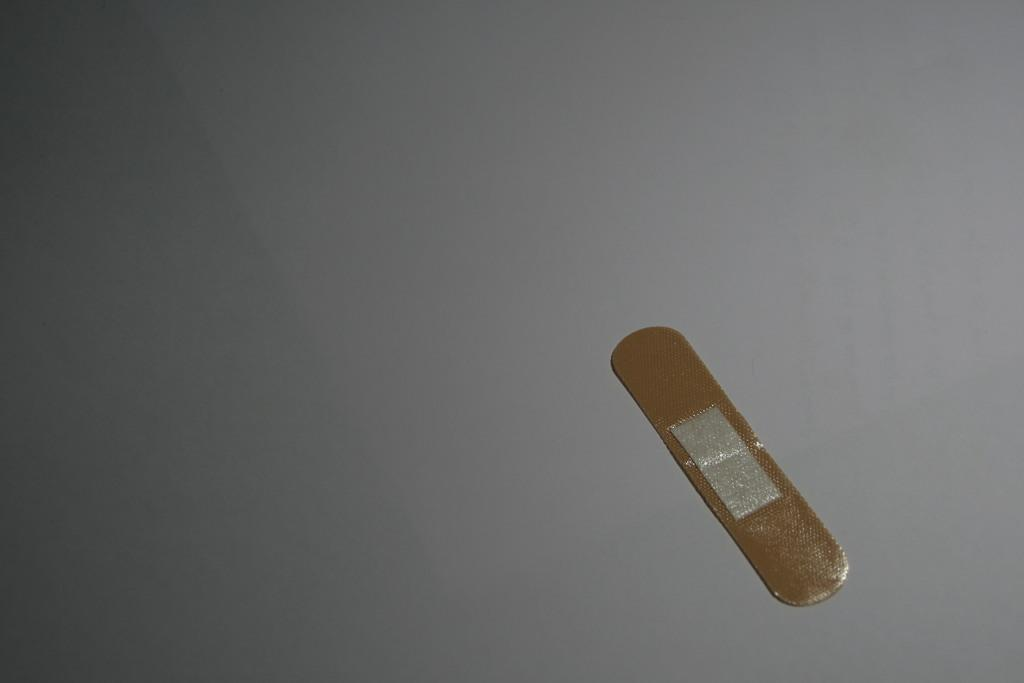What is present on the white table in the image? There is a band aid on a white color table in the image. What is the color of the table the band aid is placed on? The table is white. How many brothers does the knife in the image have? There is no knife present in the image, so it is not possible to determine the number of brothers it might have. 